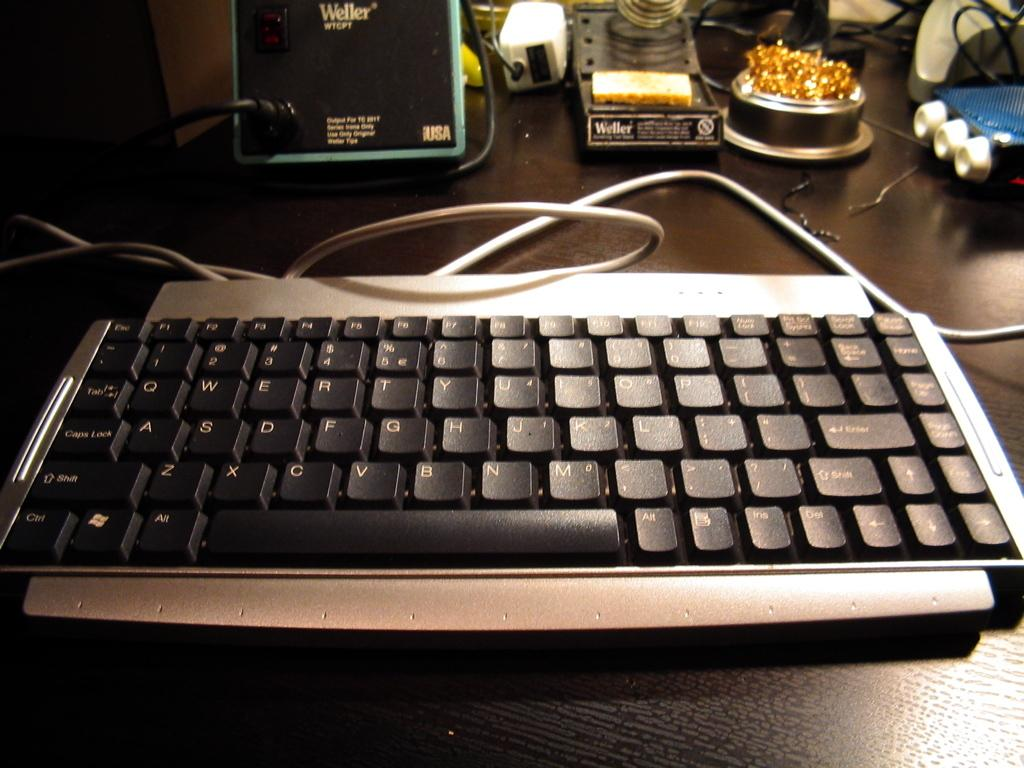<image>
Share a concise interpretation of the image provided. A desk with a computer keyboard and other items made by a company called Weller. 